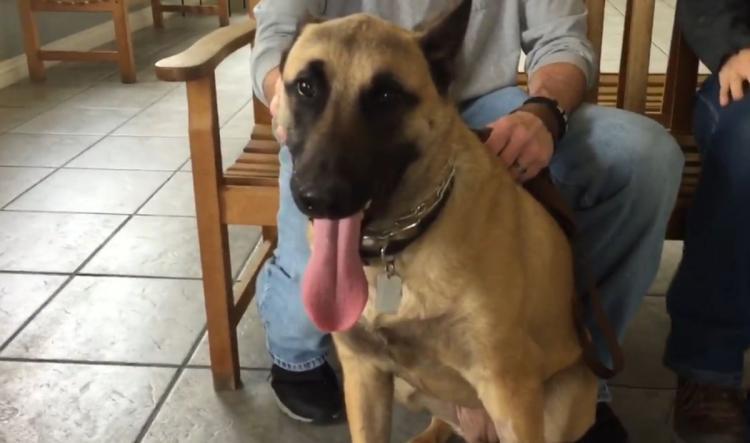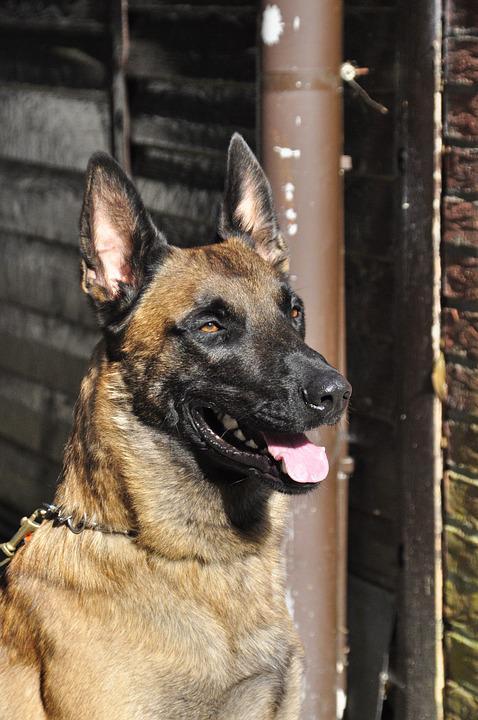The first image is the image on the left, the second image is the image on the right. For the images displayed, is the sentence "The left image contains one dog with its tongue hanging out." factually correct? Answer yes or no. Yes. The first image is the image on the left, the second image is the image on the right. Analyze the images presented: Is the assertion "The dog in the image on the right is near an area of green grass." valid? Answer yes or no. No. 